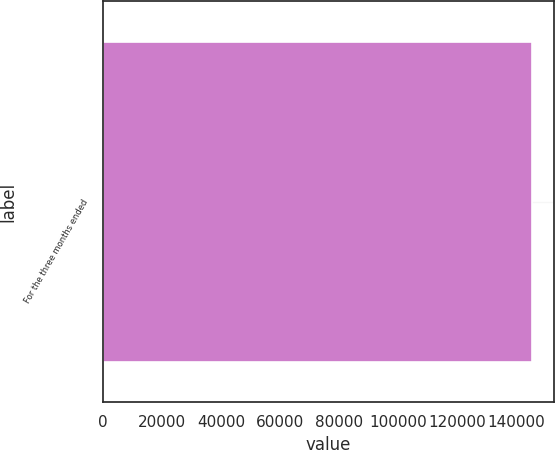Convert chart. <chart><loc_0><loc_0><loc_500><loc_500><bar_chart><fcel>For the three months ended<nl><fcel>145543<nl></chart> 